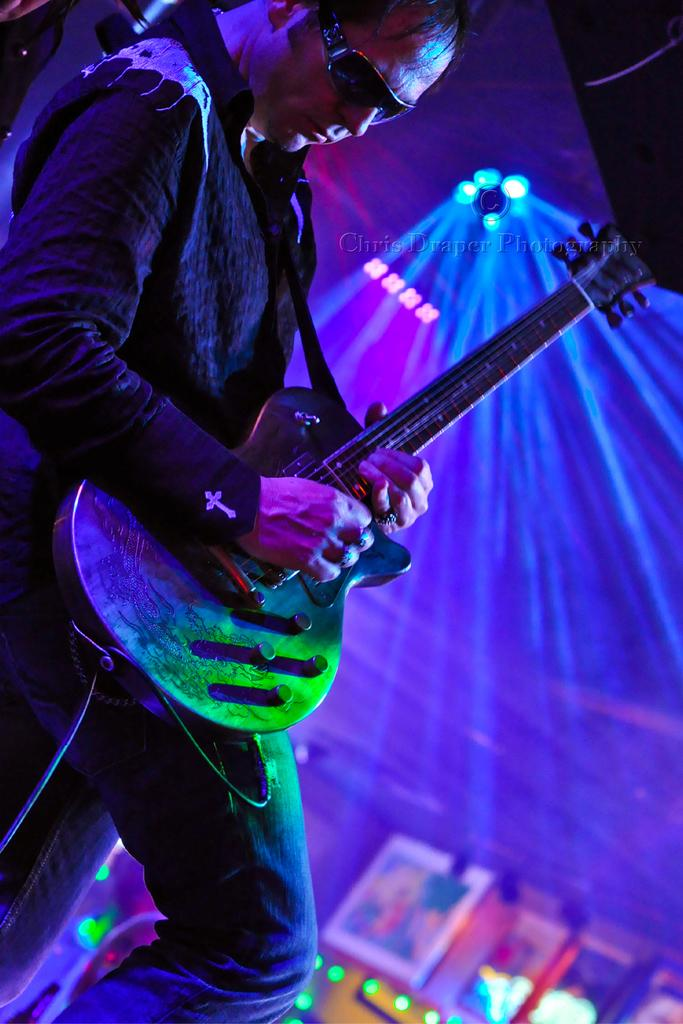Who is present in the image? There is a man in the image. What is the man wearing? The man is wearing glasses. What is the man holding in the image? The man is holding a guitar. What type of lighting is present in the image? There are spotlights in the image. What can be seen in the background of the image? There are frames in the background of the image. What type of operation is being performed on the baby in the image? There is no baby or operation present in the image; it features a man holding a guitar. What type of jam is being served in the image? There is no jam or serving of any kind present in the image. 